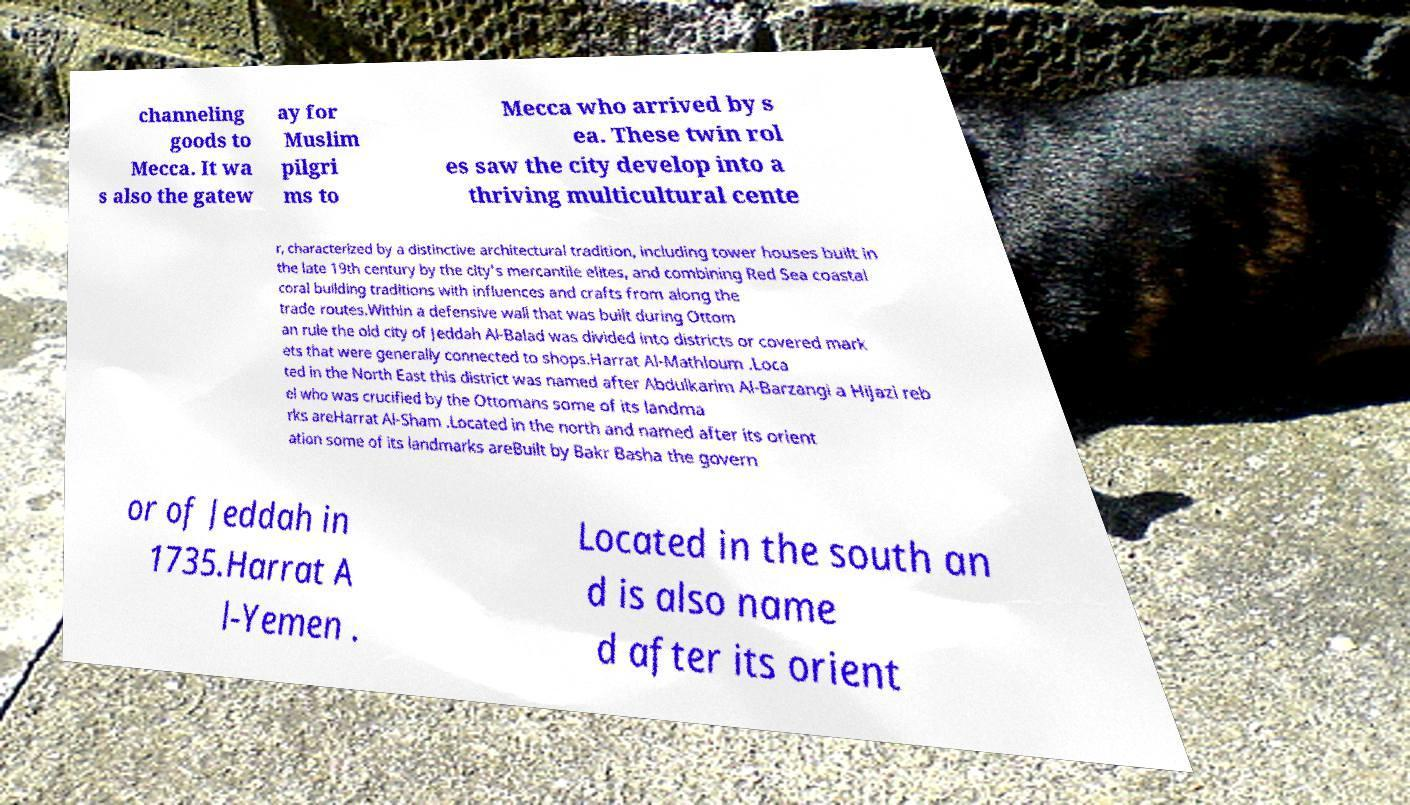What messages or text are displayed in this image? I need them in a readable, typed format. channeling goods to Mecca. It wa s also the gatew ay for Muslim pilgri ms to Mecca who arrived by s ea. These twin rol es saw the city develop into a thriving multicultural cente r, characterized by a distinctive architectural tradition, including tower houses built in the late 19th century by the city's mercantile elites, and combining Red Sea coastal coral building traditions with influences and crafts from along the trade routes.Within a defensive wall that was built during Ottom an rule the old city of Jeddah Al-Balad was divided into districts or covered mark ets that were generally connected to shops.Harrat Al-Mathloum .Loca ted in the North East this district was named after Abdulkarim Al-Barzangi a Hijazi reb el who was crucified by the Ottomans some of its landma rks areHarrat Al-Sham .Located in the north and named after its orient ation some of its landmarks areBuilt by Bakr Basha the govern or of Jeddah in 1735.Harrat A l-Yemen . Located in the south an d is also name d after its orient 